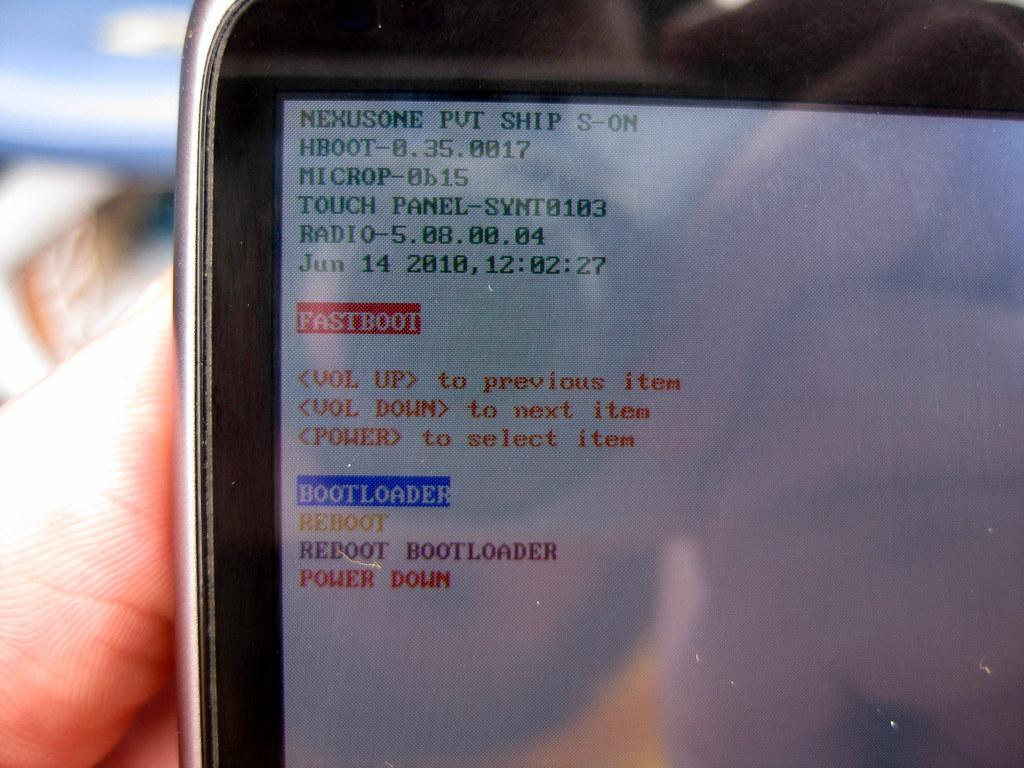<image>
Render a clear and concise summary of the photo. a text that says Fastboot on it and Reboot 